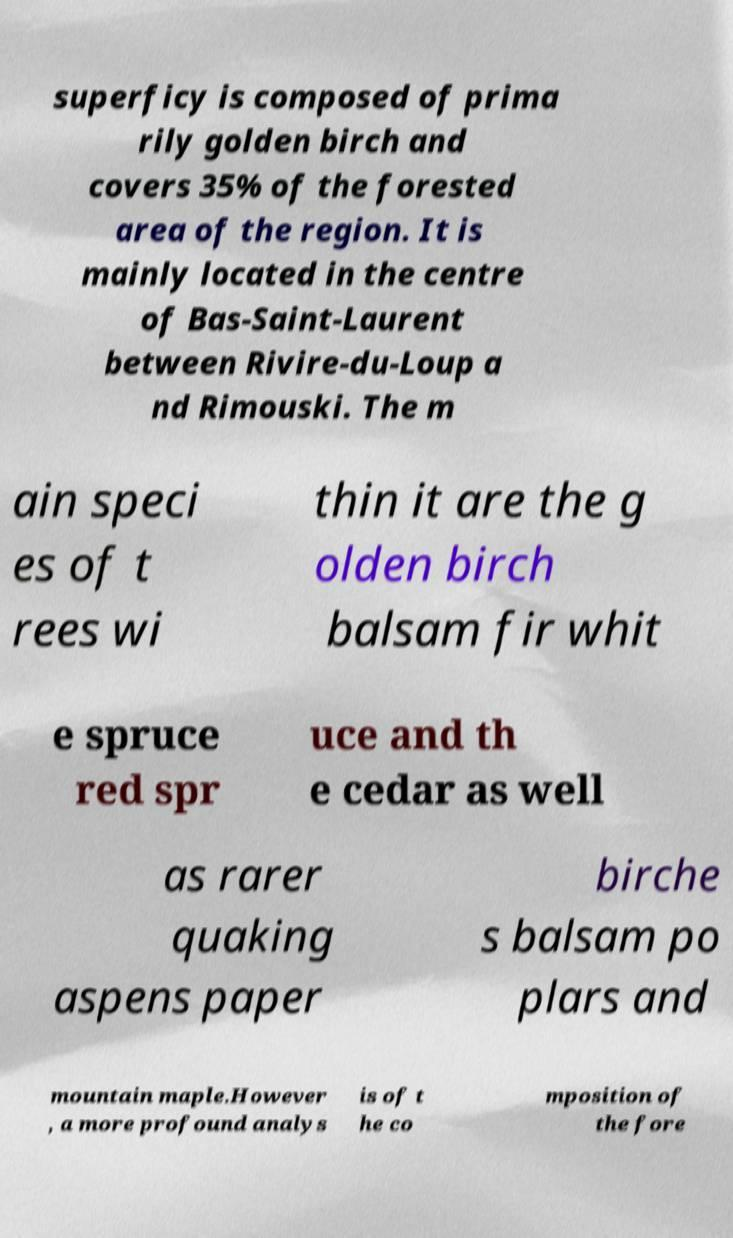Please identify and transcribe the text found in this image. superficy is composed of prima rily golden birch and covers 35% of the forested area of the region. It is mainly located in the centre of Bas-Saint-Laurent between Rivire-du-Loup a nd Rimouski. The m ain speci es of t rees wi thin it are the g olden birch balsam fir whit e spruce red spr uce and th e cedar as well as rarer quaking aspens paper birche s balsam po plars and mountain maple.However , a more profound analys is of t he co mposition of the fore 